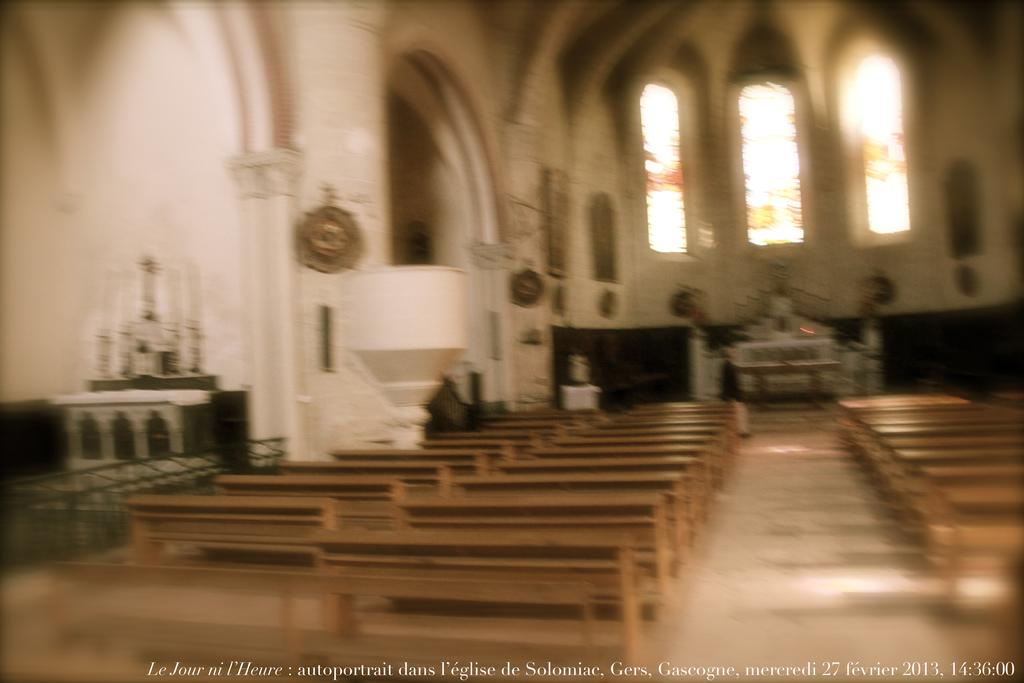What type of building is shown in the image? The image shows an inner view inside view of a church. What type of seating is available in the church? There are benches in the church. What allows natural light to enter the church? There are windows in the church. What type of lighting is present in the church? There are candles in the church. What is visible at the bottom of the image? There is text visible at the bottom of the image. Is there a fight happening in the church in the image? No, there is no fight present in the image; it shows an inner view of a peaceful church setting. 